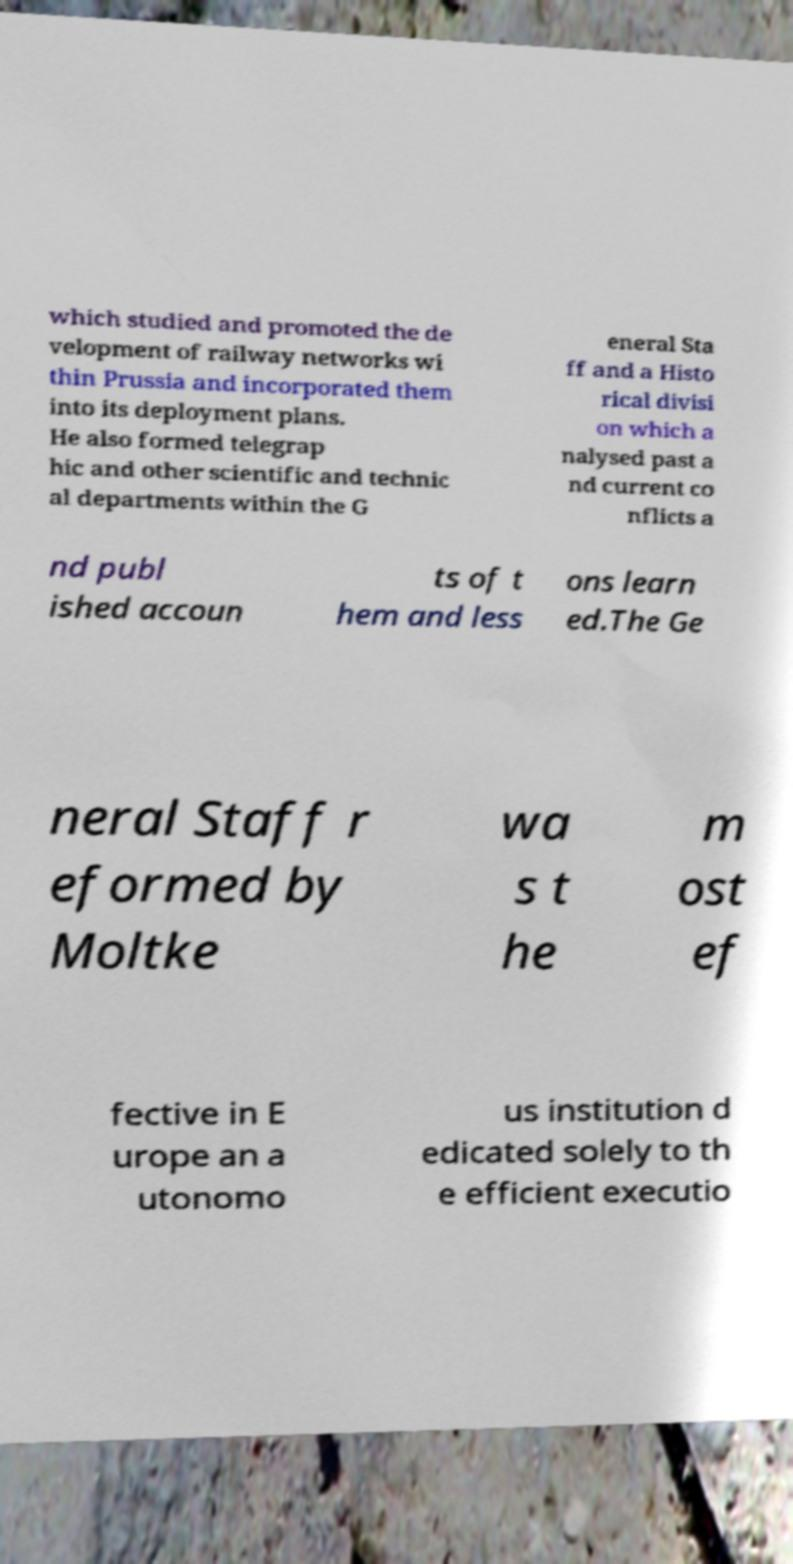Please read and relay the text visible in this image. What does it say? which studied and promoted the de velopment of railway networks wi thin Prussia and incorporated them into its deployment plans. He also formed telegrap hic and other scientific and technic al departments within the G eneral Sta ff and a Histo rical divisi on which a nalysed past a nd current co nflicts a nd publ ished accoun ts of t hem and less ons learn ed.The Ge neral Staff r eformed by Moltke wa s t he m ost ef fective in E urope an a utonomo us institution d edicated solely to th e efficient executio 